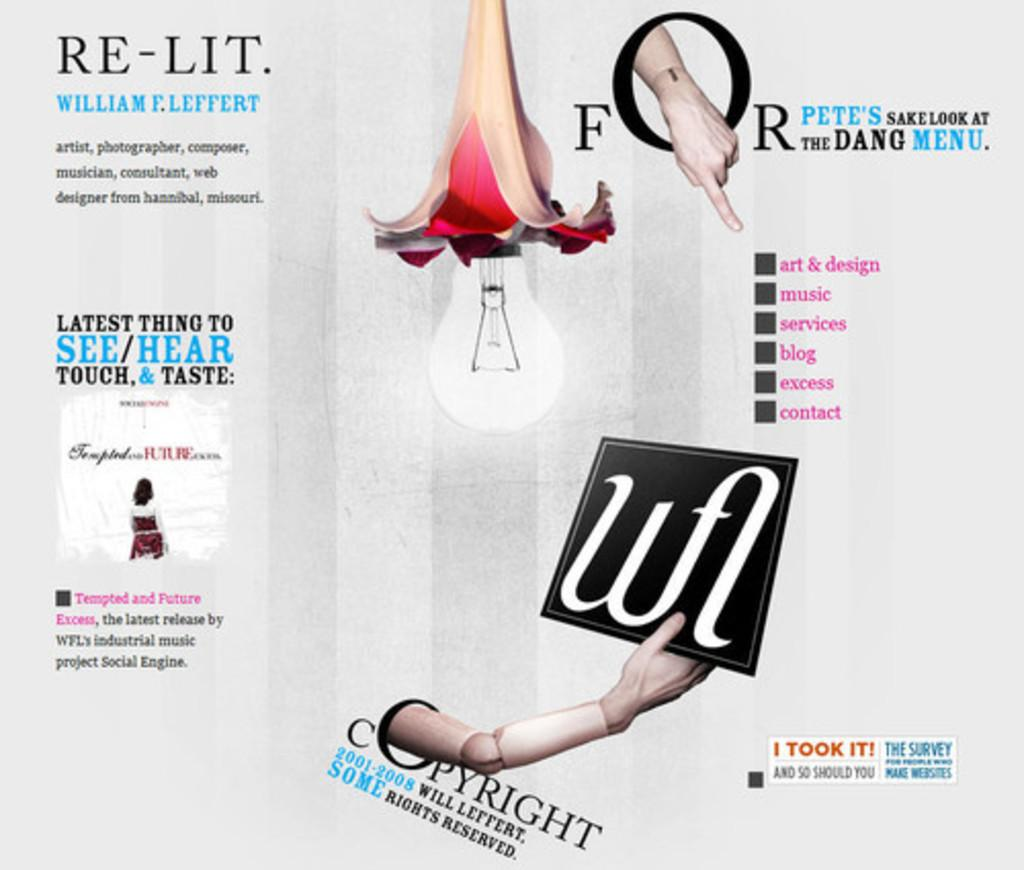What is the main subject of the image? The main subject of the image is an advertisement. What type of horse is depicted in the advertisement? There is no horse present in the image, as it features an advertisement. 